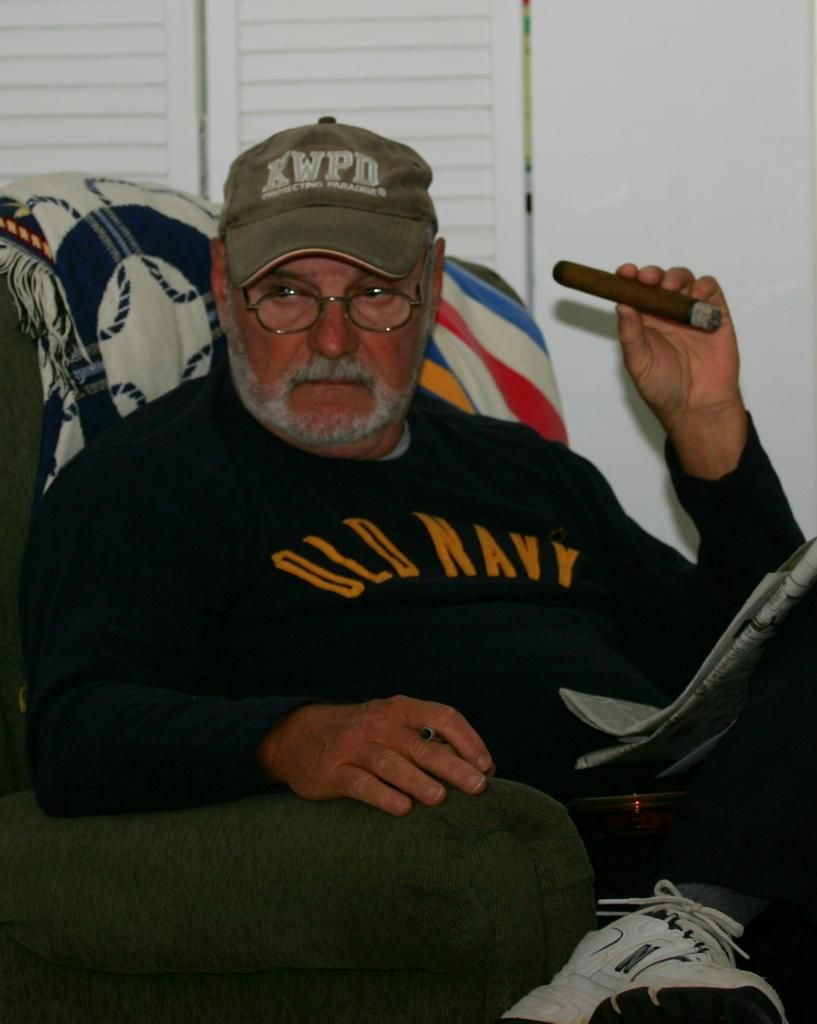What is the person in the image doing? The person is sitting on a sofa in the image. What is the person holding in their hand? The person is holding a cigar in their hand. What can be seen in the background of the image? There is a window and a wall in the background of the image. Where is the image taken? The image is taken in a room. What type of flowers can be seen on the expert's desk in the image? There are no flowers or experts present in the image; it features a person sitting on a sofa holding a cigar in a room with a window and a wall in the background. 